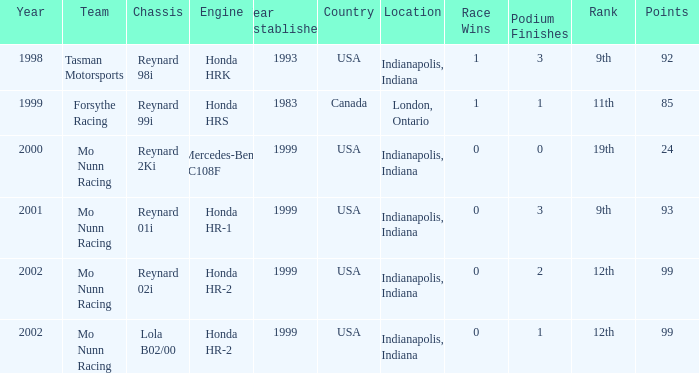What is the total number of points of the honda hr-1 engine? 1.0. Can you parse all the data within this table? {'header': ['Year', 'Team', 'Chassis', 'Engine', 'Year Established', 'Country', 'Location', 'Race Wins', 'Podium Finishes', 'Rank', 'Points'], 'rows': [['1998', 'Tasman Motorsports', 'Reynard 98i', 'Honda HRK', '1993', 'USA', 'Indianapolis, Indiana', '1', '3', '9th', '92'], ['1999', 'Forsythe Racing', 'Reynard 99i', 'Honda HRS', '1983', 'Canada', 'London, Ontario', '1', '1', '11th', '85'], ['2000', 'Mo Nunn Racing', 'Reynard 2Ki', 'Mercedes-Benz IC108F', '1999', 'USA', 'Indianapolis, Indiana', '0', '0', '19th', '24'], ['2001', 'Mo Nunn Racing', 'Reynard 01i', 'Honda HR-1', '1999', 'USA', 'Indianapolis, Indiana', '0', '3', '9th', '93'], ['2002', 'Mo Nunn Racing', 'Reynard 02i', 'Honda HR-2', '1999', 'USA', 'Indianapolis, Indiana', '0', '2', '12th', '99'], ['2002', 'Mo Nunn Racing', 'Lola B02/00', 'Honda HR-2', '1999', 'USA', 'Indianapolis, Indiana', '0', '1', '12th', '99']]} 